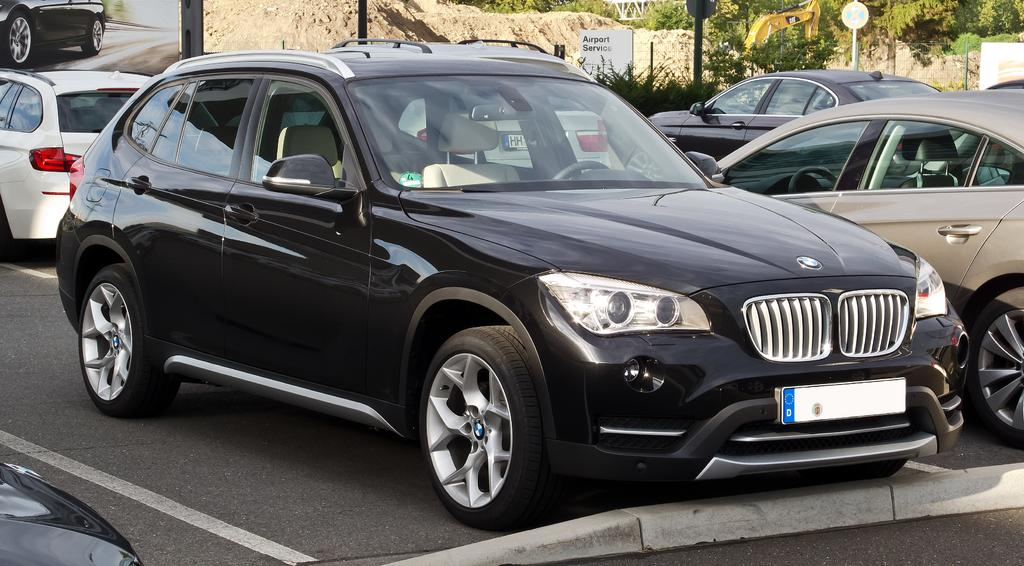What type of vehicles can be seen in the image? There are cars in the image. What other objects or features are present in the image? There are trees and boards visible in the image. What is the primary surface visible in the image? There is a road visible at the bottom of the image. What type of pen is being used to draw on the trees in the image? There is no pen or drawing activity present in the image; it features cars, trees, boards, and a road. 